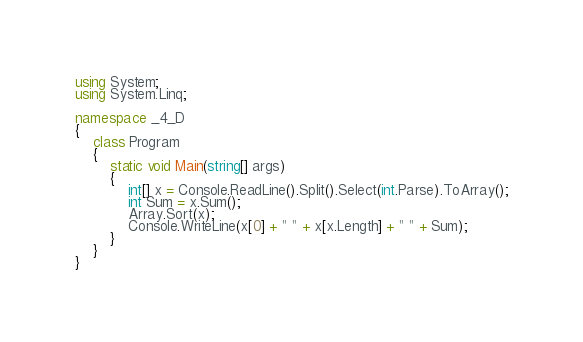<code> <loc_0><loc_0><loc_500><loc_500><_C#_>using System;
using System.Linq;

namespace _4_D
{
    class Program
    {
        static void Main(string[] args)
        {
            int[] x = Console.ReadLine().Split().Select(int.Parse).ToArray();
            int Sum = x.Sum();
            Array.Sort(x);
            Console.WriteLine(x[0] + " " + x[x.Length] + " " + Sum);
        }
    }
}</code> 